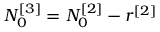<formula> <loc_0><loc_0><loc_500><loc_500>N _ { 0 } ^ { [ 3 ] } = N _ { 0 } ^ { [ 2 ] } - r ^ { [ 2 ] }</formula> 